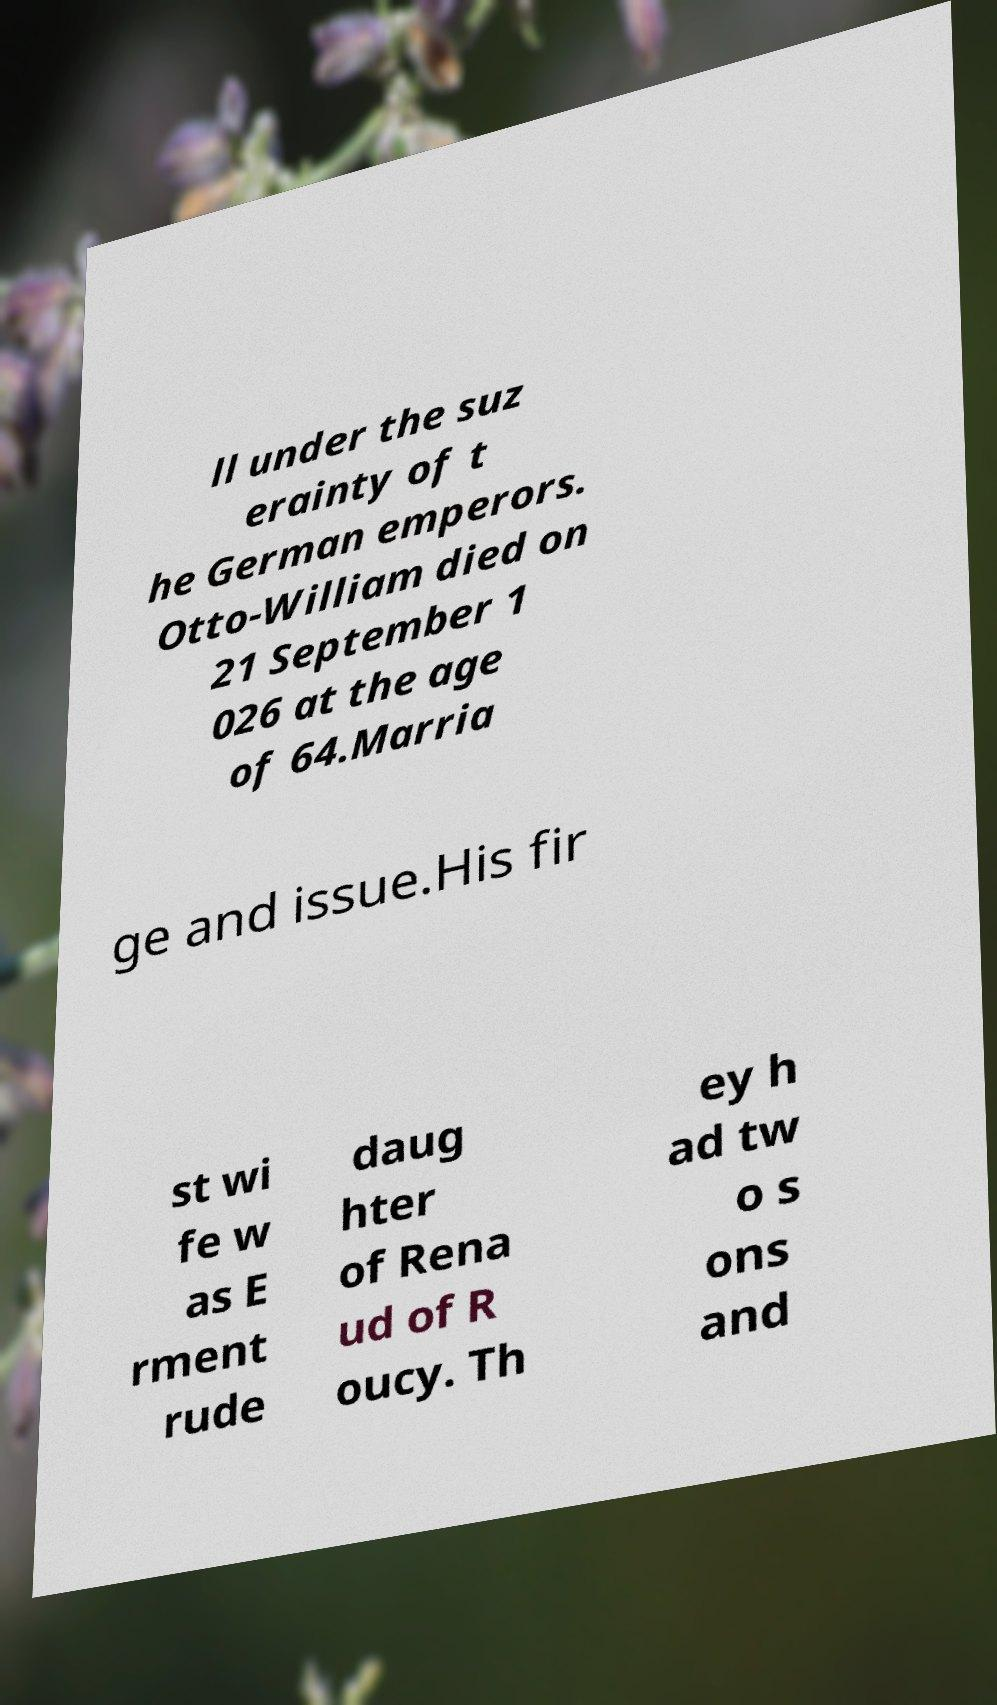There's text embedded in this image that I need extracted. Can you transcribe it verbatim? ll under the suz erainty of t he German emperors. Otto-William died on 21 September 1 026 at the age of 64.Marria ge and issue.His fir st wi fe w as E rment rude daug hter of Rena ud of R oucy. Th ey h ad tw o s ons and 